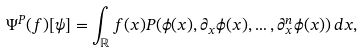<formula> <loc_0><loc_0><loc_500><loc_500>\Psi ^ { P } ( f ) [ \psi ] = \int _ { \mathbb { R } } f ( x ) P ( \phi ( x ) , \partial _ { x } \phi ( x ) , \dots , \partial _ { x } ^ { n } \phi ( x ) ) \, d x ,</formula> 